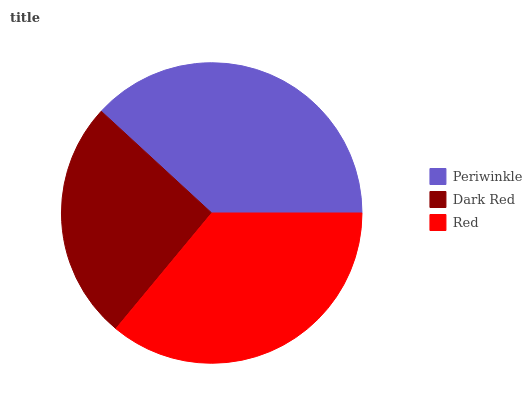Is Dark Red the minimum?
Answer yes or no. Yes. Is Periwinkle the maximum?
Answer yes or no. Yes. Is Red the minimum?
Answer yes or no. No. Is Red the maximum?
Answer yes or no. No. Is Red greater than Dark Red?
Answer yes or no. Yes. Is Dark Red less than Red?
Answer yes or no. Yes. Is Dark Red greater than Red?
Answer yes or no. No. Is Red less than Dark Red?
Answer yes or no. No. Is Red the high median?
Answer yes or no. Yes. Is Red the low median?
Answer yes or no. Yes. Is Periwinkle the high median?
Answer yes or no. No. Is Periwinkle the low median?
Answer yes or no. No. 